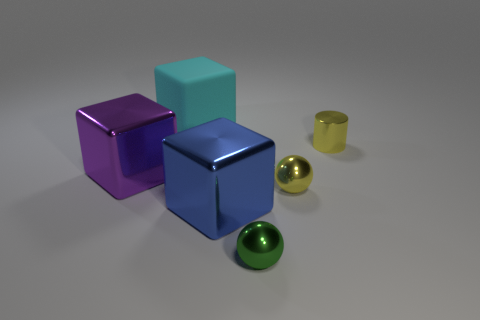Is there any other thing that is the same material as the large cyan block?
Give a very brief answer. No. What number of other small things are the same shape as the tiny green metallic object?
Your response must be concise. 1. Does the yellow object behind the big purple shiny cube have the same material as the blue cube that is to the left of the green object?
Your response must be concise. Yes. What is the size of the metal block that is in front of the ball on the right side of the tiny green metallic sphere?
Provide a short and direct response. Large. There is a purple object that is the same shape as the large cyan matte object; what is its material?
Provide a short and direct response. Metal. Do the tiny thing in front of the tiny yellow sphere and the tiny yellow object that is in front of the small yellow metal cylinder have the same shape?
Make the answer very short. Yes. Is the number of red spheres greater than the number of tiny shiny spheres?
Give a very brief answer. No. How big is the green sphere?
Make the answer very short. Small. How many other things are there of the same color as the metallic cylinder?
Keep it short and to the point. 1. Do the large object that is right of the matte cube and the cyan cube have the same material?
Your answer should be compact. No. 